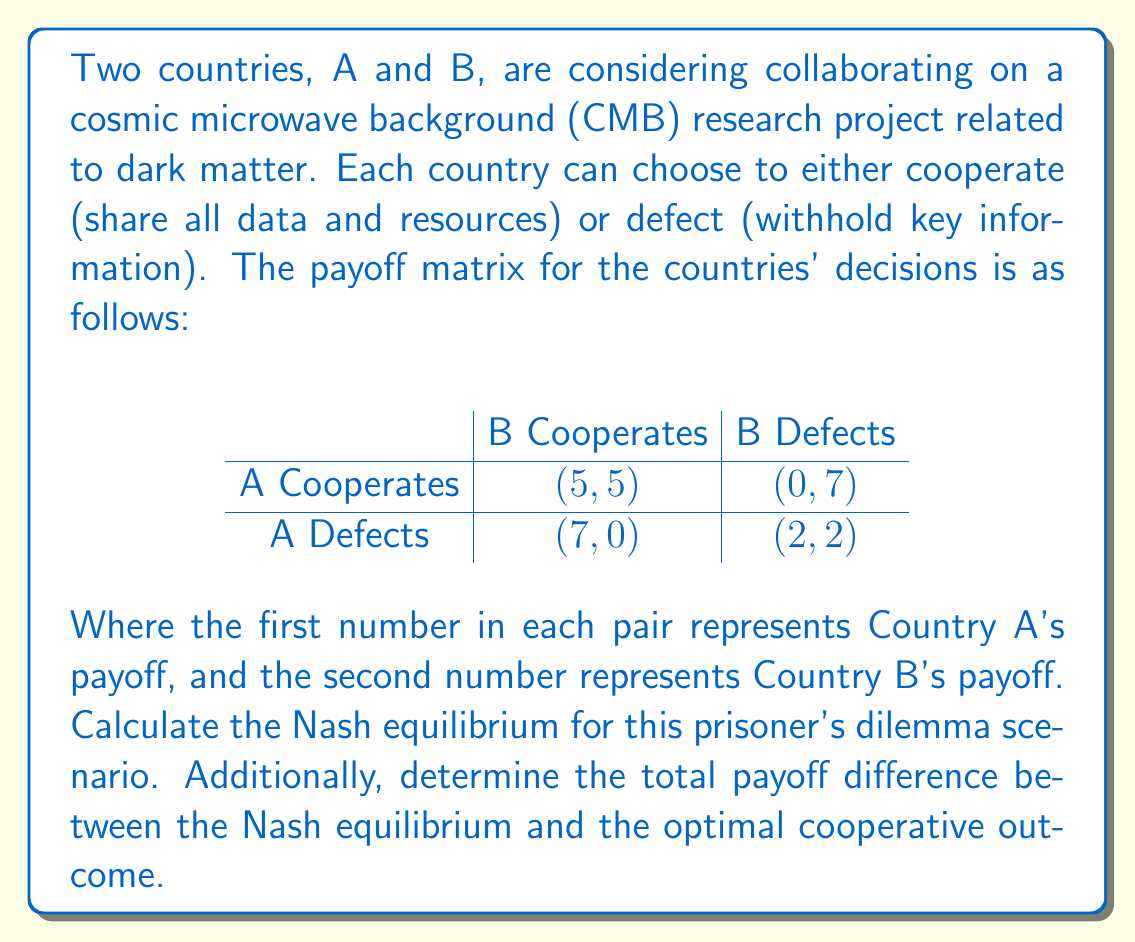Provide a solution to this math problem. To solve this problem, we'll follow these steps:

1. Identify the dominant strategy for each country
2. Determine the Nash equilibrium
3. Calculate the total payoff for the Nash equilibrium
4. Calculate the total payoff for the optimal cooperative outcome
5. Find the difference between the two payoffs

Step 1: Identify the dominant strategy

For Country A:
- If B cooperates: Defect (7) > Cooperate (5)
- If B defects: Defect (2) > Cooperate (0)

For Country B:
- If A cooperates: Defect (7) > Cooperate (5)
- If A defects: Defect (2) > Cooperate (0)

The dominant strategy for both countries is to defect.

Step 2: Determine the Nash equilibrium

Since both countries have defection as their dominant strategy, the Nash equilibrium is (Defect, Defect).

Step 3: Calculate the total payoff for the Nash equilibrium

At (Defect, Defect), the payoff is (2, 2).
Total payoff = $2 + 2 = 4$

Step 4: Calculate the total payoff for the optimal cooperative outcome

The optimal cooperative outcome is (Cooperate, Cooperate) with a payoff of (5, 5).
Total payoff = $5 + 5 = 10$

Step 5: Find the difference between the two payoffs

Difference = Optimal cooperative payoff - Nash equilibrium payoff
            = $10 - 4 = 6$

Therefore, the Nash equilibrium is (Defect, Defect), and the total payoff difference between the Nash equilibrium and the optimal cooperative outcome is 6.
Answer: Nash equilibrium: (Defect, Defect)
Total payoff difference: 6 